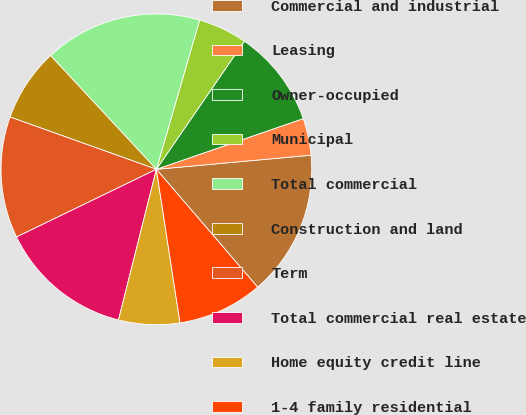Convert chart. <chart><loc_0><loc_0><loc_500><loc_500><pie_chart><fcel>Commercial and industrial<fcel>Leasing<fcel>Owner-occupied<fcel>Municipal<fcel>Total commercial<fcel>Construction and land<fcel>Term<fcel>Total commercial real estate<fcel>Home equity credit line<fcel>1-4 family residential<nl><fcel>15.15%<fcel>3.84%<fcel>10.13%<fcel>5.1%<fcel>16.41%<fcel>7.61%<fcel>12.64%<fcel>13.9%<fcel>6.35%<fcel>8.87%<nl></chart> 